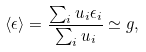<formula> <loc_0><loc_0><loc_500><loc_500>\langle \epsilon \rangle = \frac { \sum _ { i } u _ { i } \epsilon _ { i } } { \sum _ { i } u _ { i } } \simeq g ,</formula> 